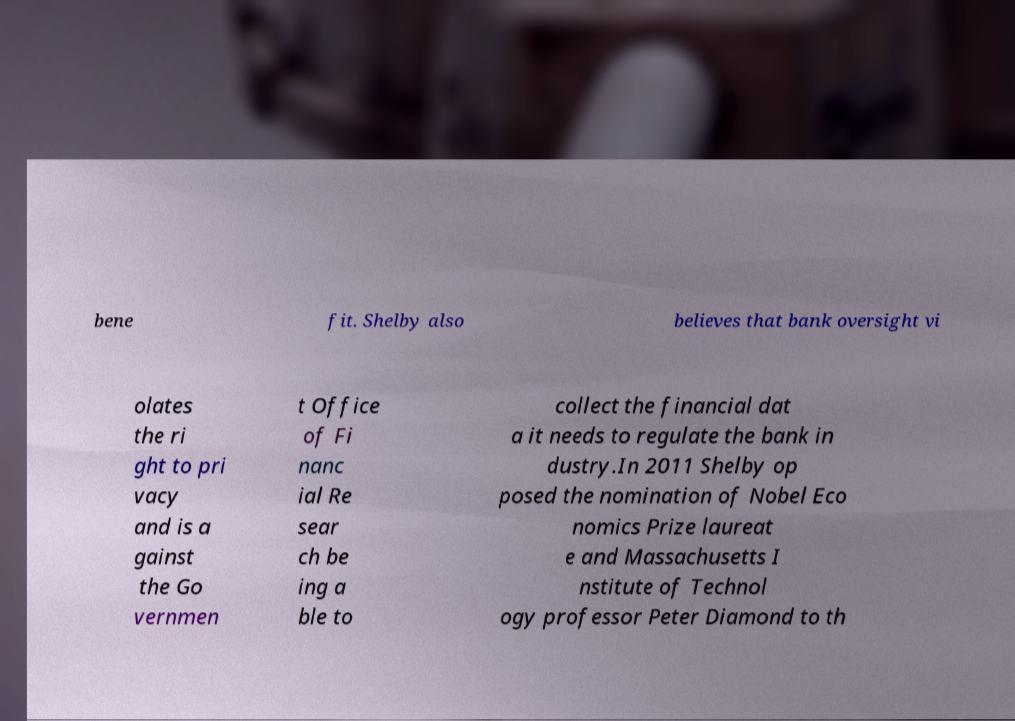Could you assist in decoding the text presented in this image and type it out clearly? bene fit. Shelby also believes that bank oversight vi olates the ri ght to pri vacy and is a gainst the Go vernmen t Office of Fi nanc ial Re sear ch be ing a ble to collect the financial dat a it needs to regulate the bank in dustry.In 2011 Shelby op posed the nomination of Nobel Eco nomics Prize laureat e and Massachusetts I nstitute of Technol ogy professor Peter Diamond to th 